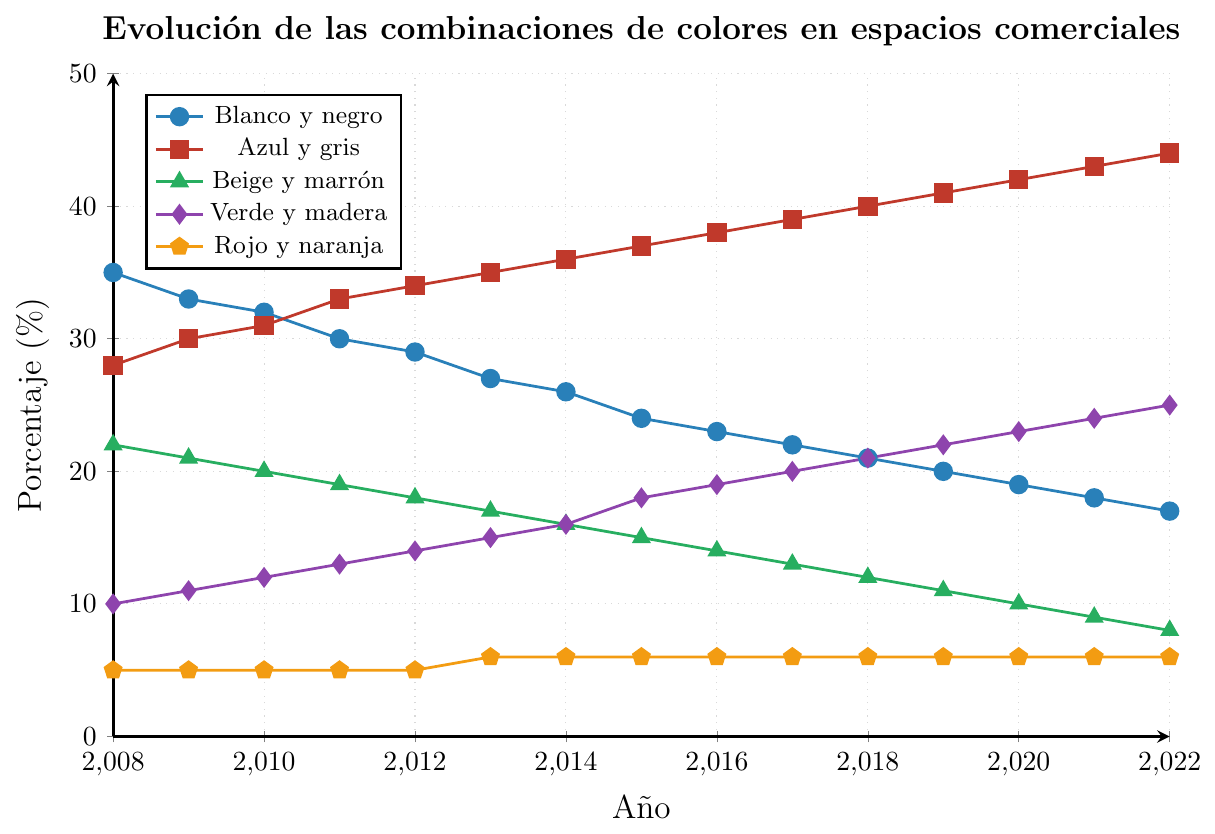¿Cuál es la combinación de colores que disminuyó más su uso a lo largo de los años? Observando las líneas en el gráfico, la combinación "Blanco y negro" muestra una clara disminución, pasando de 35% en 2008 a 17% en 2022.
Answer: Blanco y negro ¿Cuántos puntos porcentuales aumentó el uso de la combinación "Verde y madera" desde 2008 hasta 2022? El valor en 2008 es 10 y en 2022 es 25. La diferencia es 25 - 10 = 15 puntos porcentuales.
Answer: 15 ¿Qué combinación de colores tuvo el menor cambio en porcentaje durante los últimos 15 años? La línea "Rojo y naranja" se mantiene casi constante, variando solo ligeramente de 5% a 6% a lo largo de los años.
Answer: Rojo y naranja Entre "Azul y gris" y "Beige y marrón", ¿cuál obtuvo un mayor uso en 2015? En 2015, "Azul y gris" está en 37% y "Beige y marrón" en 15%. Comparando estos valores, "Azul y gris" tiene un mayor uso.
Answer: Azul y gris ¿Cuál es la tasa de cambio promedio anual de la combinación "Azul y gris" entre 2008 y 2022? La diferencia total es 44 - 28 = 16. Dividiéndolo por el número de años (2022 - 2008 = 14), la tasa de cambio promedio anual es 16 / 14 ≈ 1.14% por año.
Answer: 1.14% ¿En qué año la combinación "Blanco y negro" tuvo el mismo porcentaje de uso que la combinación "Azul y gris" tuvo en 2008? En 2008, "Azul y gris" tenía 28%. La línea de "Blanco y negro" muestra 28% en 2013.
Answer: 2013 ¿Cuál fue la combinación de colores que tuvo un aumento constante durante todos los años presentados en el gráfico? La línea de "Azul y gris" muestra un aumento constante en cada año desde 2008 hasta 2022.
Answer: Azul y gris Si combinamos los porcentajes de "Verde y madera" y "Rojo y naranja" en 2010, ¿cuál es su suma? En 2010, "Verde y madera" está en 12% y "Rojo y naranja" en 5%. La suma es 12 + 5 = 17%.
Answer: 17 Comparando los porcentajes en 2020, ¿cuál es mayor, "Blanco y negro" o "Beige y marrón"? En 2020, "Blanco y negro" está en 19% y "Beige y marrón" está en 10%. Comparando estos valores, "Blanco y negro" es mayor.
Answer: Blanco y negro 